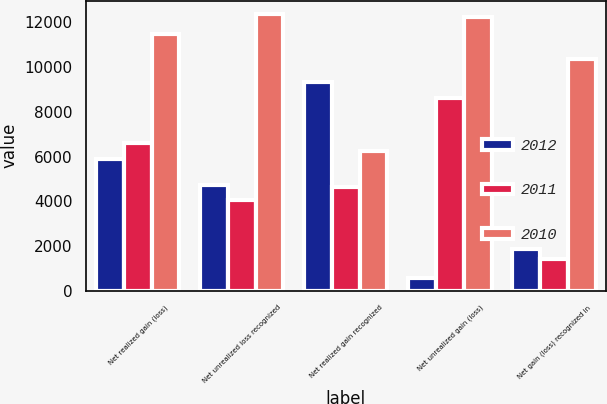Convert chart. <chart><loc_0><loc_0><loc_500><loc_500><stacked_bar_chart><ecel><fcel>Net realized gain (loss)<fcel>Net unrealized loss recognized<fcel>Net realized gain recognized<fcel>Net unrealized gain (loss)<fcel>Net gain (loss) recognized in<nl><fcel>2012<fcel>5899<fcel>4720<fcel>9312<fcel>570<fcel>1877<nl><fcel>2011<fcel>6604<fcel>4062<fcel>4633<fcel>8606<fcel>1431<nl><fcel>2010<fcel>11470<fcel>12345<fcel>6251.5<fcel>12247<fcel>10353<nl></chart> 